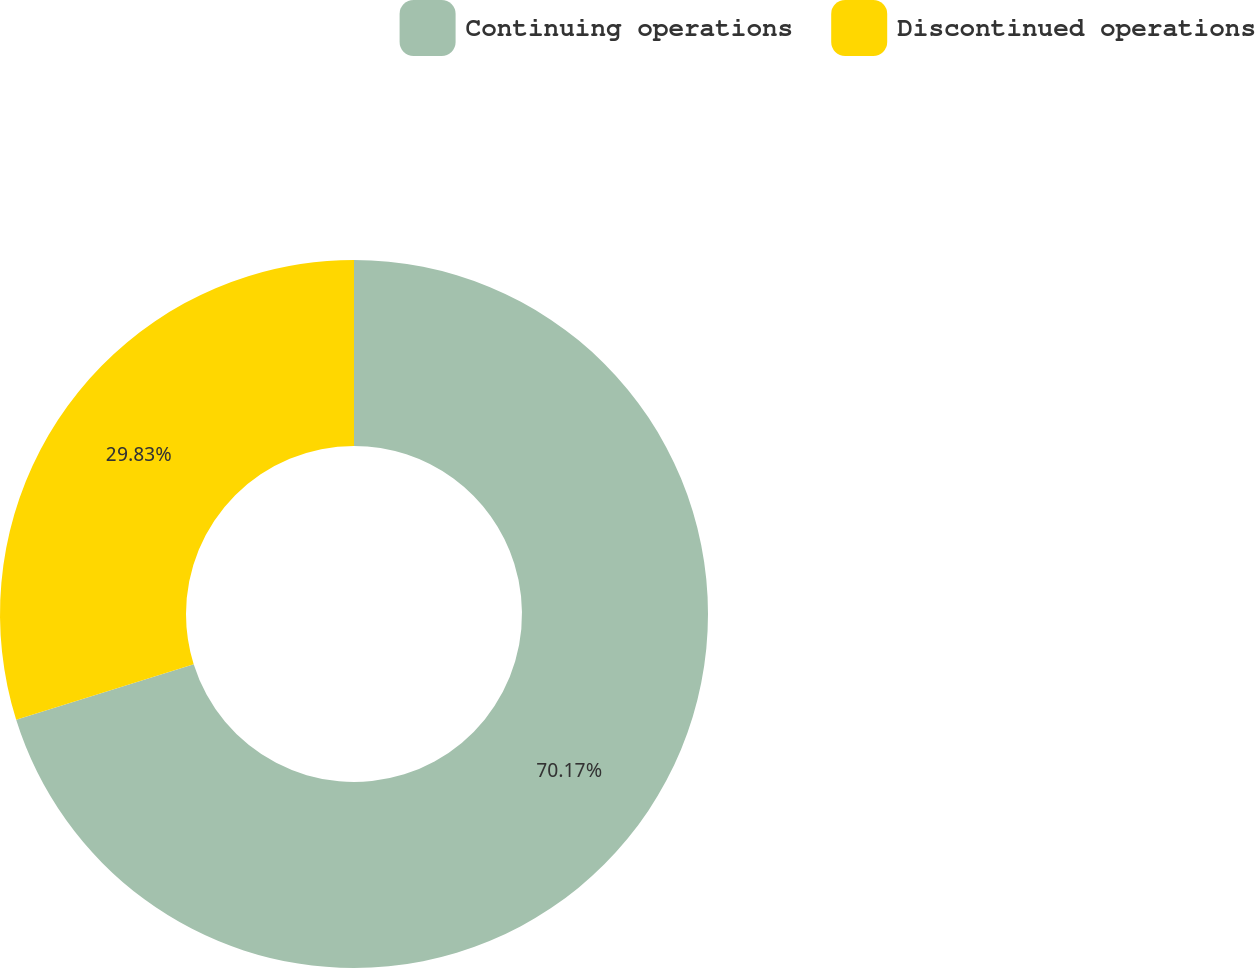<chart> <loc_0><loc_0><loc_500><loc_500><pie_chart><fcel>Continuing operations<fcel>Discontinued operations<nl><fcel>70.17%<fcel>29.83%<nl></chart> 